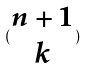Convert formula to latex. <formula><loc_0><loc_0><loc_500><loc_500>( \begin{matrix} n + 1 \\ k \end{matrix} )</formula> 